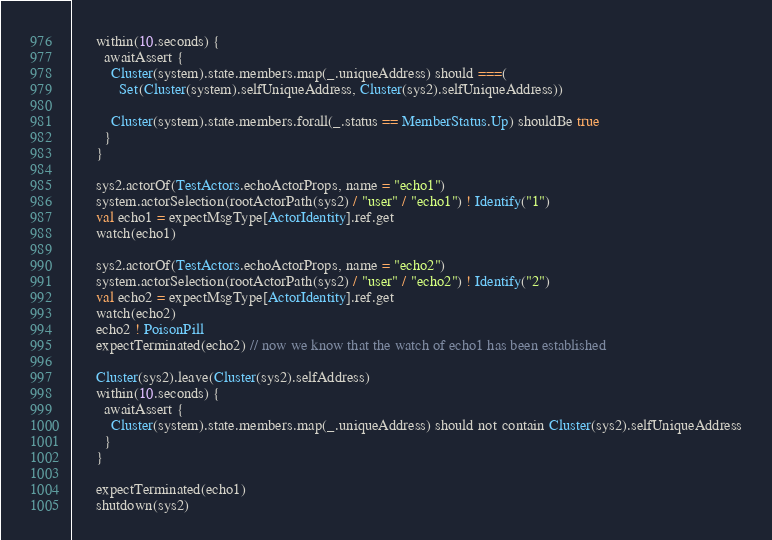Convert code to text. <code><loc_0><loc_0><loc_500><loc_500><_Scala_>      within(10.seconds) {
        awaitAssert {
          Cluster(system).state.members.map(_.uniqueAddress) should ===(
            Set(Cluster(system).selfUniqueAddress, Cluster(sys2).selfUniqueAddress))

          Cluster(system).state.members.forall(_.status == MemberStatus.Up) shouldBe true
        }
      }

      sys2.actorOf(TestActors.echoActorProps, name = "echo1")
      system.actorSelection(rootActorPath(sys2) / "user" / "echo1") ! Identify("1")
      val echo1 = expectMsgType[ActorIdentity].ref.get
      watch(echo1)

      sys2.actorOf(TestActors.echoActorProps, name = "echo2")
      system.actorSelection(rootActorPath(sys2) / "user" / "echo2") ! Identify("2")
      val echo2 = expectMsgType[ActorIdentity].ref.get
      watch(echo2)
      echo2 ! PoisonPill
      expectTerminated(echo2) // now we know that the watch of echo1 has been established

      Cluster(sys2).leave(Cluster(sys2).selfAddress)
      within(10.seconds) {
        awaitAssert {
          Cluster(system).state.members.map(_.uniqueAddress) should not contain Cluster(sys2).selfUniqueAddress
        }
      }

      expectTerminated(echo1)
      shutdown(sys2)
</code> 